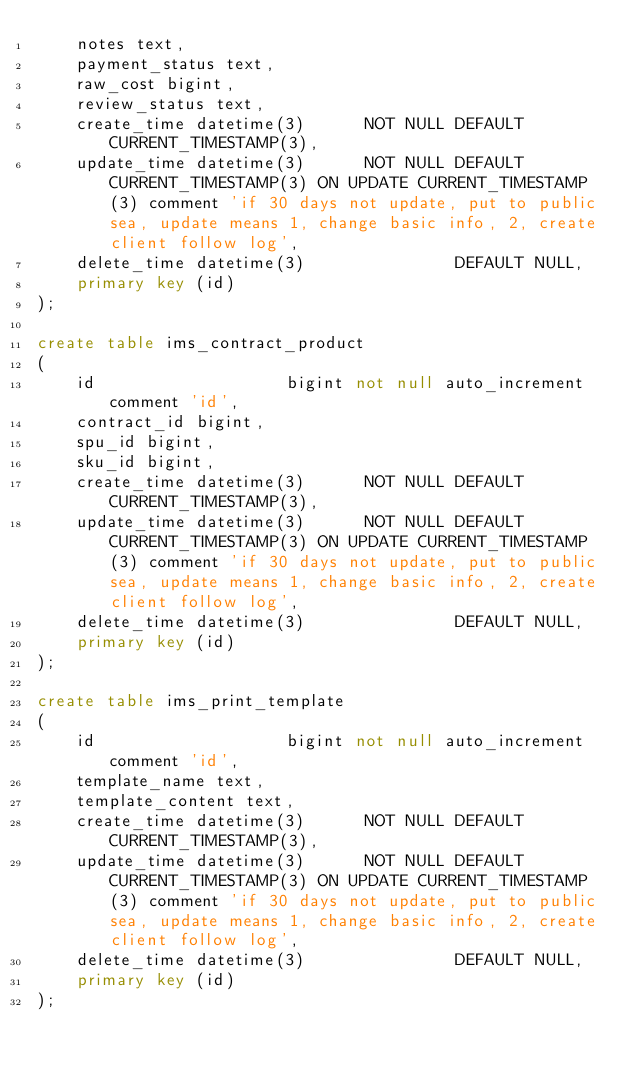Convert code to text. <code><loc_0><loc_0><loc_500><loc_500><_SQL_>    notes text,
    payment_status text,
    raw_cost bigint,
    review_status text,
    create_time datetime(3)      NOT NULL DEFAULT CURRENT_TIMESTAMP(3),
    update_time datetime(3)      NOT NULL DEFAULT CURRENT_TIMESTAMP(3) ON UPDATE CURRENT_TIMESTAMP(3) comment 'if 30 days not update, put to public sea, update means 1, change basic info, 2, create client follow log',
    delete_time datetime(3)               DEFAULT NULL,
    primary key (id)
);

create table ims_contract_product
(
    id                   bigint not null auto_increment comment 'id',
    contract_id bigint,
    spu_id bigint,
    sku_id bigint,
    create_time datetime(3)      NOT NULL DEFAULT CURRENT_TIMESTAMP(3),
    update_time datetime(3)      NOT NULL DEFAULT CURRENT_TIMESTAMP(3) ON UPDATE CURRENT_TIMESTAMP(3) comment 'if 30 days not update, put to public sea, update means 1, change basic info, 2, create client follow log',
    delete_time datetime(3)               DEFAULT NULL,
    primary key (id)
);

create table ims_print_template
(
    id                   bigint not null auto_increment comment 'id',
    template_name text,
    template_content text,
    create_time datetime(3)      NOT NULL DEFAULT CURRENT_TIMESTAMP(3),
    update_time datetime(3)      NOT NULL DEFAULT CURRENT_TIMESTAMP(3) ON UPDATE CURRENT_TIMESTAMP(3) comment 'if 30 days not update, put to public sea, update means 1, change basic info, 2, create client follow log',
    delete_time datetime(3)               DEFAULT NULL,
    primary key (id)
);</code> 